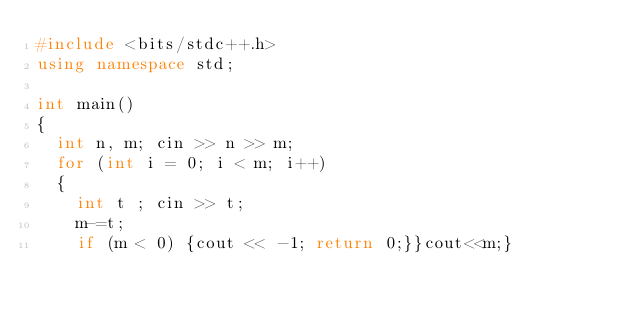<code> <loc_0><loc_0><loc_500><loc_500><_C++_>#include <bits/stdc++.h>
using namespace std;

int main()
{
  int n, m; cin >> n >> m;
  for (int i = 0; i < m; i++)
  {
    int t ; cin >> t;
    m-=t;
    if (m < 0) {cout << -1; return 0;}}cout<<m;}</code> 